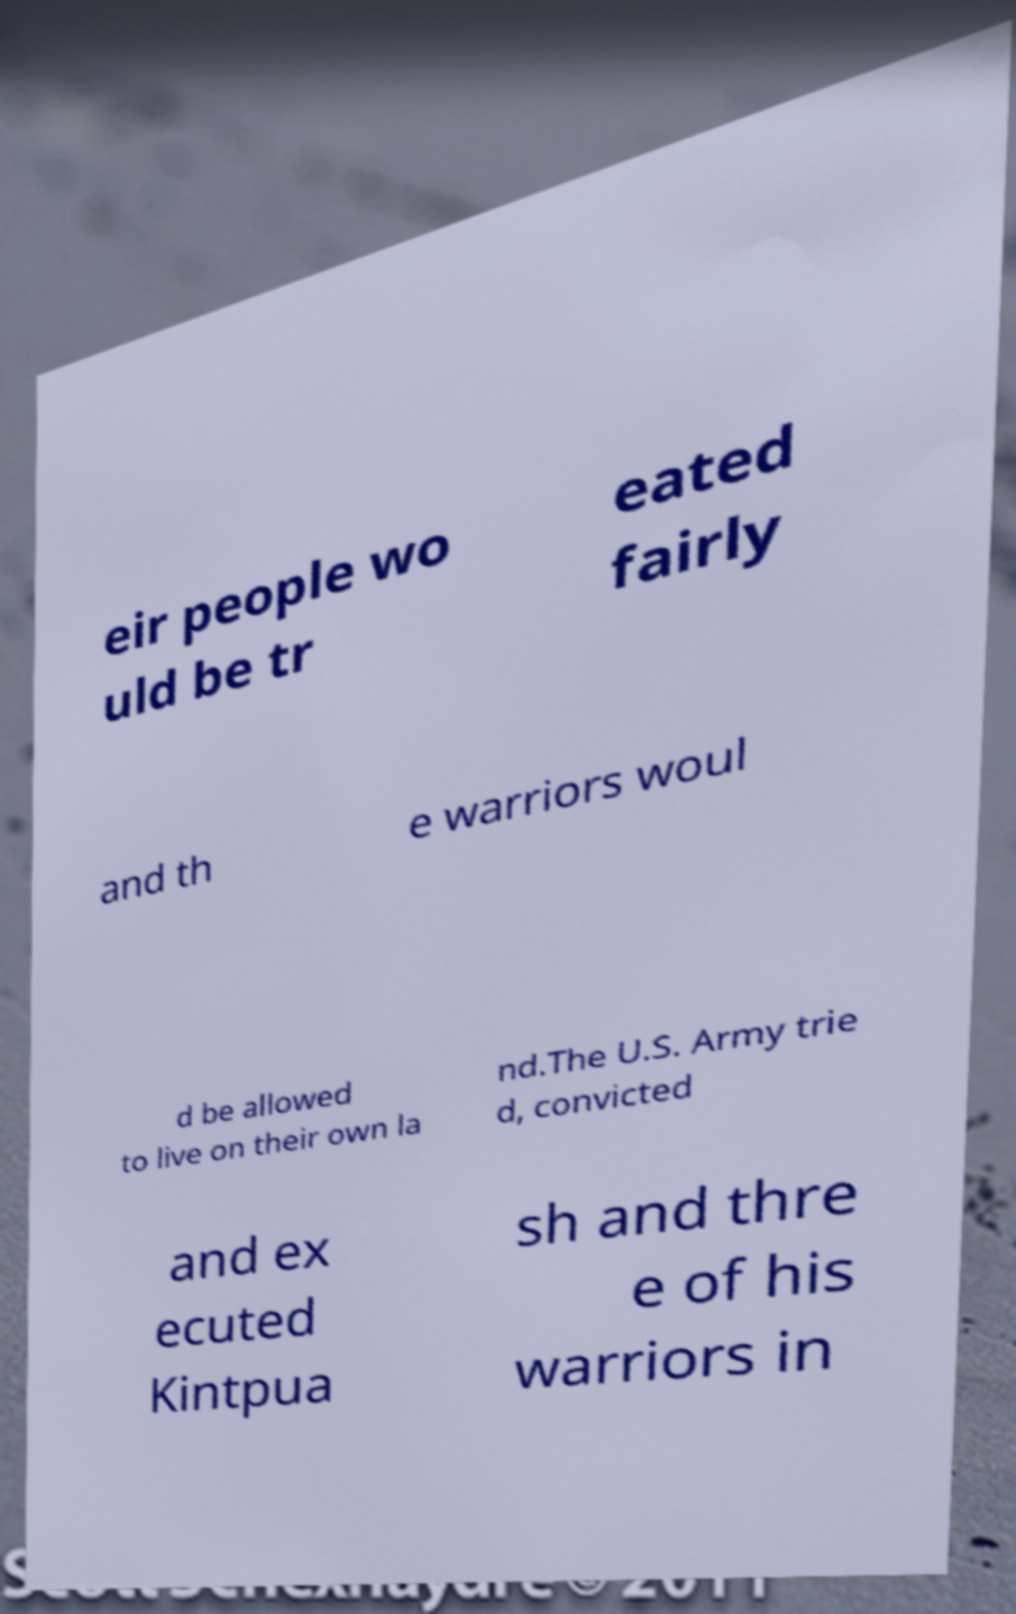What messages or text are displayed in this image? I need them in a readable, typed format. eir people wo uld be tr eated fairly and th e warriors woul d be allowed to live on their own la nd.The U.S. Army trie d, convicted and ex ecuted Kintpua sh and thre e of his warriors in 